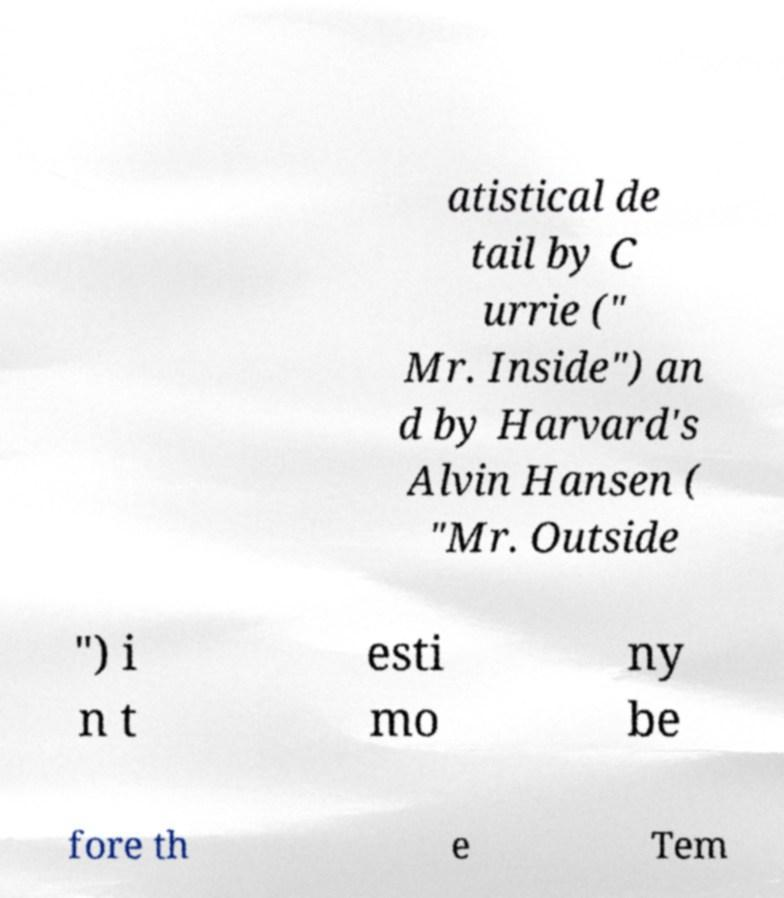There's text embedded in this image that I need extracted. Can you transcribe it verbatim? atistical de tail by C urrie (" Mr. Inside") an d by Harvard's Alvin Hansen ( "Mr. Outside ") i n t esti mo ny be fore th e Tem 